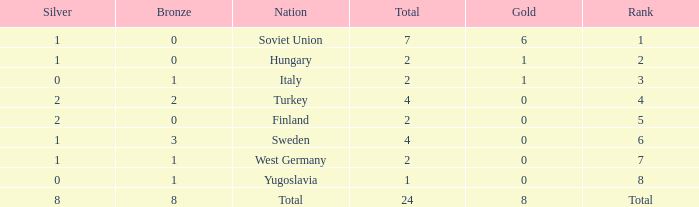What is the lowest Bronze, when Gold is less than 0? None. Parse the full table. {'header': ['Silver', 'Bronze', 'Nation', 'Total', 'Gold', 'Rank'], 'rows': [['1', '0', 'Soviet Union', '7', '6', '1'], ['1', '0', 'Hungary', '2', '1', '2'], ['0', '1', 'Italy', '2', '1', '3'], ['2', '2', 'Turkey', '4', '0', '4'], ['2', '0', 'Finland', '2', '0', '5'], ['1', '3', 'Sweden', '4', '0', '6'], ['1', '1', 'West Germany', '2', '0', '7'], ['0', '1', 'Yugoslavia', '1', '0', '8'], ['8', '8', 'Total', '24', '8', 'Total']]} 